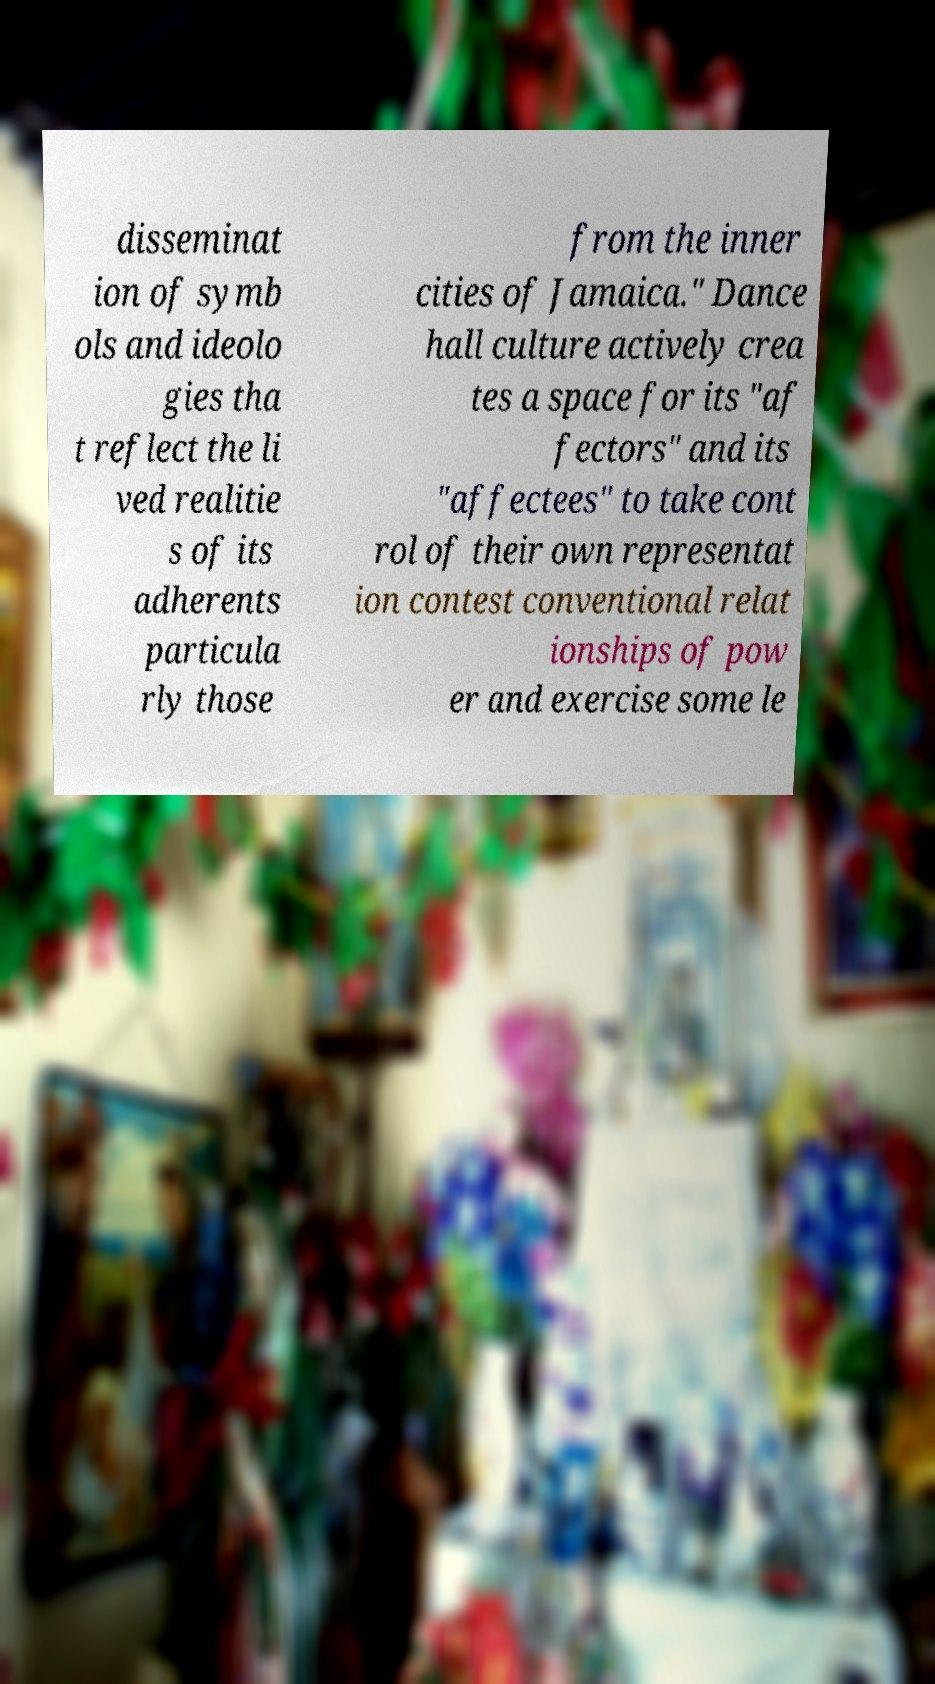Can you accurately transcribe the text from the provided image for me? disseminat ion of symb ols and ideolo gies tha t reflect the li ved realitie s of its adherents particula rly those from the inner cities of Jamaica." Dance hall culture actively crea tes a space for its "af fectors" and its "affectees" to take cont rol of their own representat ion contest conventional relat ionships of pow er and exercise some le 